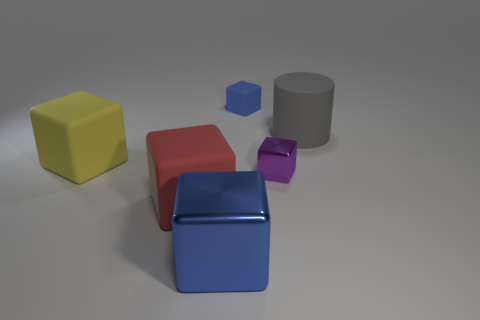Subtract all brown balls. How many blue cubes are left? 2 Subtract all blue blocks. How many blocks are left? 3 Subtract all purple cubes. How many cubes are left? 4 Add 3 large purple metal things. How many objects exist? 9 Subtract all cyan blocks. Subtract all purple balls. How many blocks are left? 5 Subtract all cylinders. How many objects are left? 5 Add 4 yellow rubber things. How many yellow rubber things exist? 5 Subtract 0 gray spheres. How many objects are left? 6 Subtract all cyan cubes. Subtract all large gray things. How many objects are left? 5 Add 3 large red cubes. How many large red cubes are left? 4 